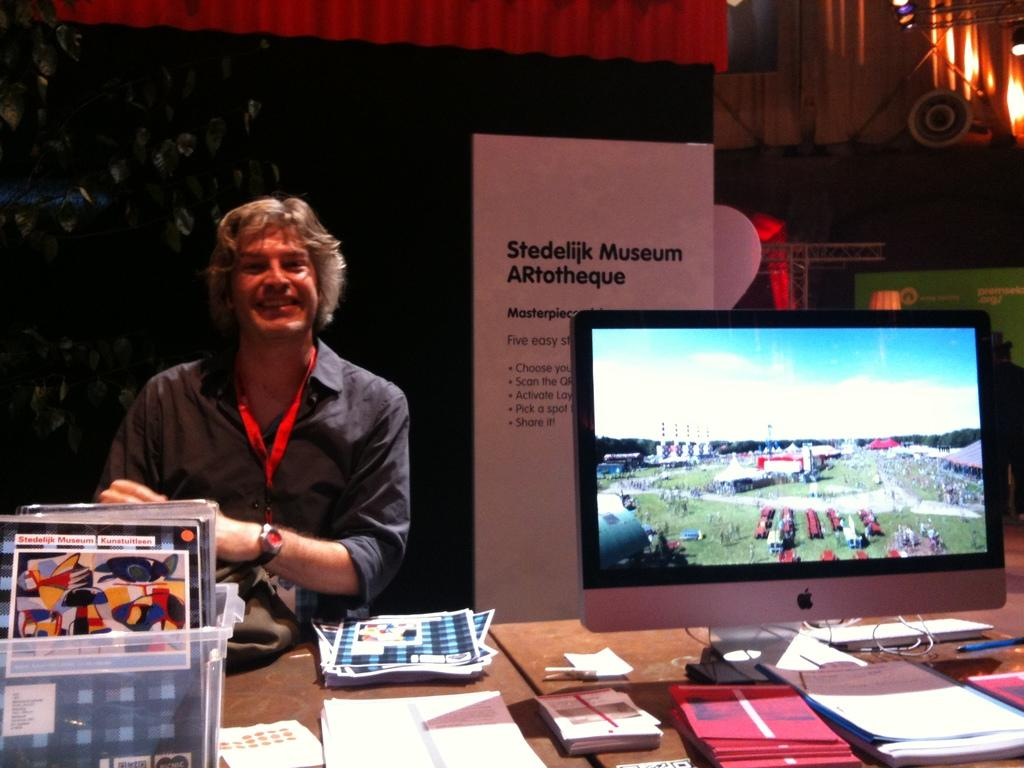<image>
Summarize the visual content of the image. A smiling man sits next to a sign that reads Stedelijk Museum ARtotheque. 